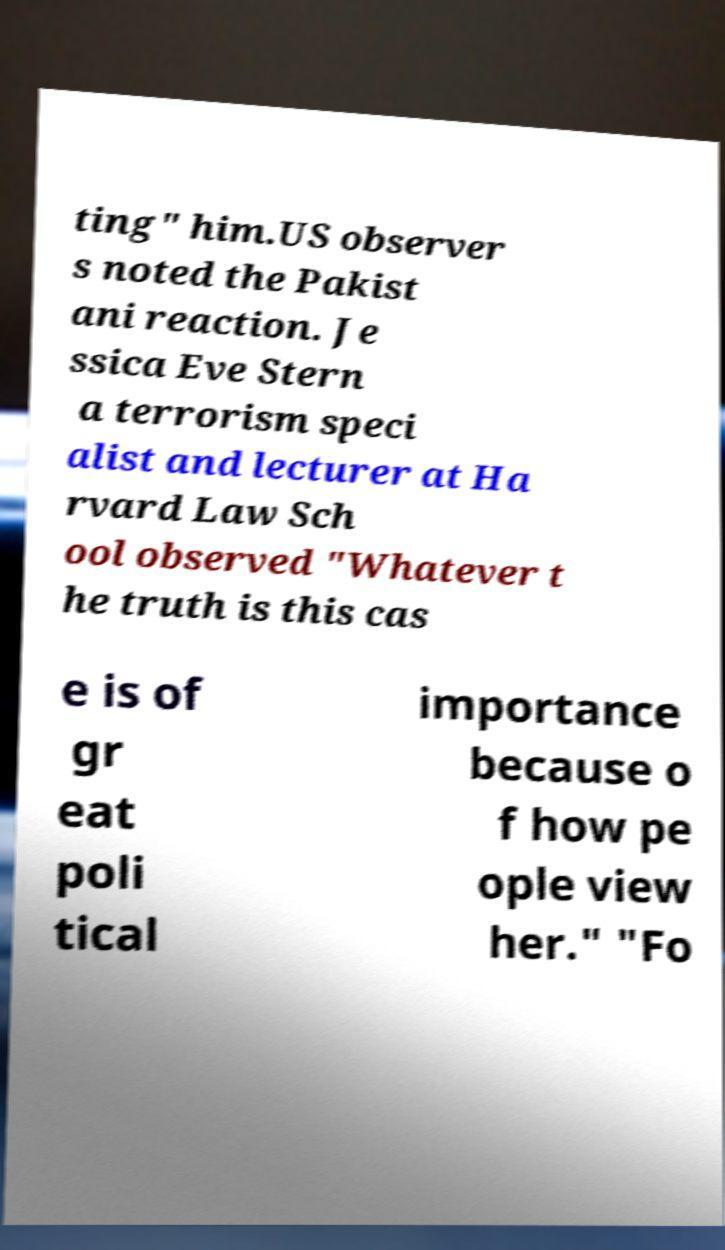Could you assist in decoding the text presented in this image and type it out clearly? ting" him.US observer s noted the Pakist ani reaction. Je ssica Eve Stern a terrorism speci alist and lecturer at Ha rvard Law Sch ool observed "Whatever t he truth is this cas e is of gr eat poli tical importance because o f how pe ople view her." "Fo 